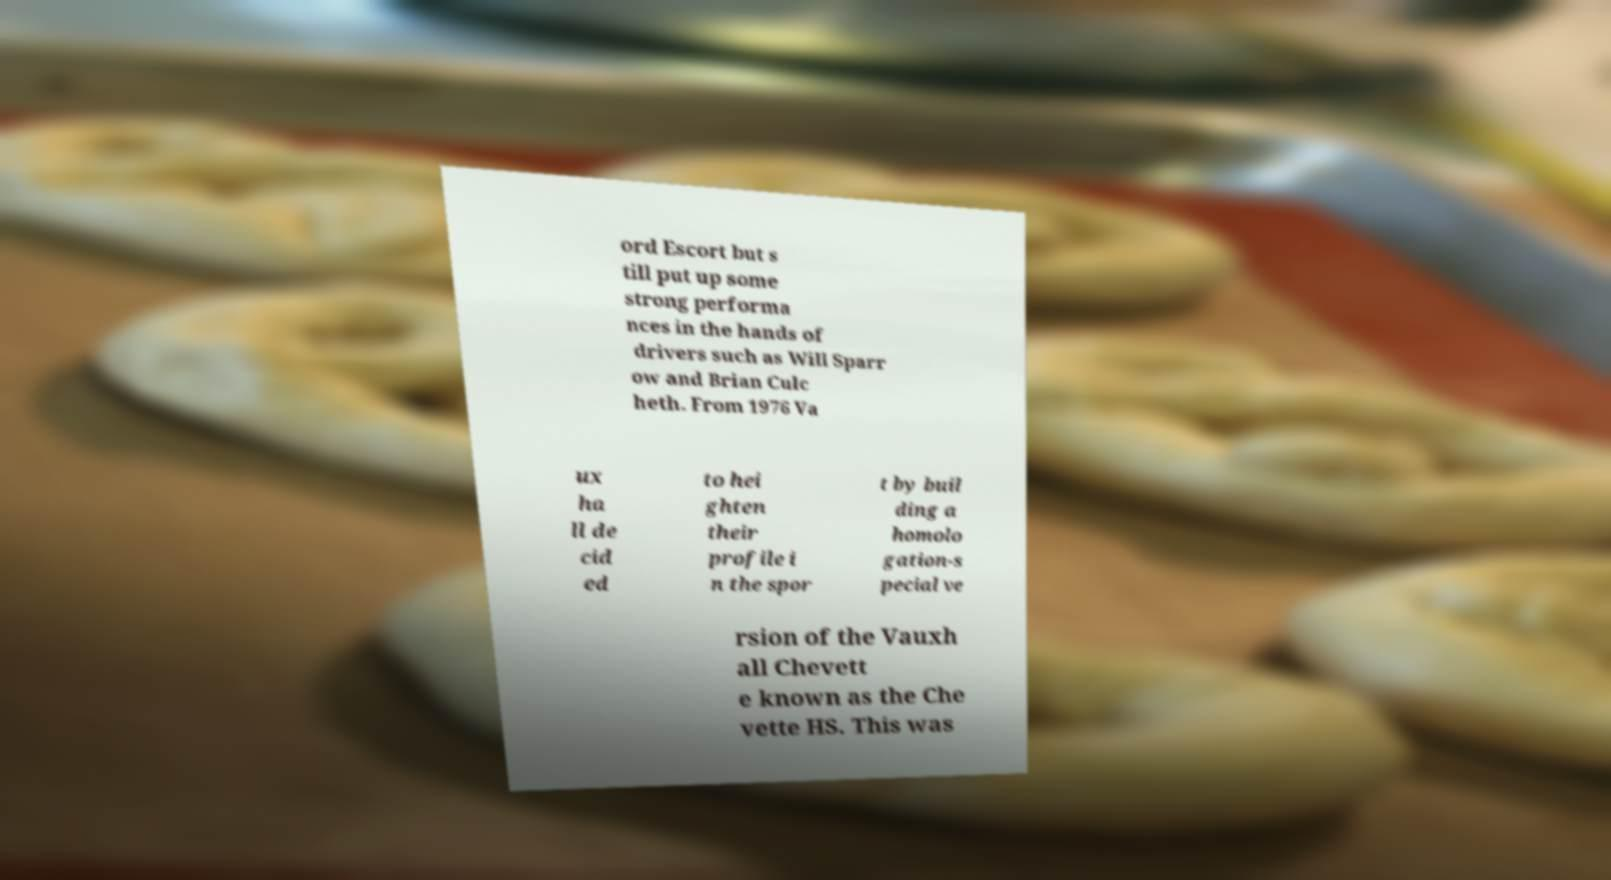There's text embedded in this image that I need extracted. Can you transcribe it verbatim? ord Escort but s till put up some strong performa nces in the hands of drivers such as Will Sparr ow and Brian Culc heth. From 1976 Va ux ha ll de cid ed to hei ghten their profile i n the spor t by buil ding a homolo gation-s pecial ve rsion of the Vauxh all Chevett e known as the Che vette HS. This was 